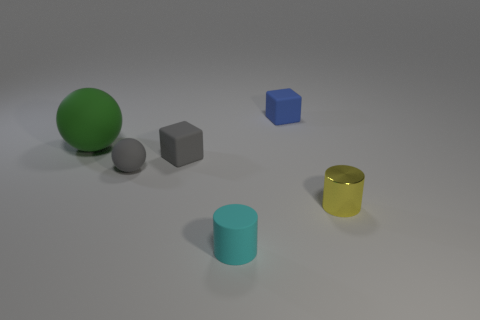How many big objects are either green rubber balls or cyan shiny cubes?
Offer a very short reply. 1. There is a block that is the same color as the tiny ball; what is it made of?
Keep it short and to the point. Rubber. Is the number of big purple matte cylinders less than the number of gray spheres?
Make the answer very short. Yes. Do the gray ball that is behind the tiny matte cylinder and the thing behind the large green ball have the same size?
Offer a terse response. Yes. What number of green objects are either tiny spheres or big balls?
Provide a short and direct response. 1. What is the size of the object that is the same color as the small ball?
Offer a very short reply. Small. Is the number of blue matte things greater than the number of blue metallic blocks?
Keep it short and to the point. Yes. Is the color of the rubber cylinder the same as the tiny sphere?
Provide a succinct answer. No. What number of things are either big rubber objects or small cubes in front of the green sphere?
Provide a short and direct response. 2. Are there fewer matte cubes that are to the right of the small metal cylinder than tiny cyan cylinders behind the blue object?
Provide a short and direct response. No. 